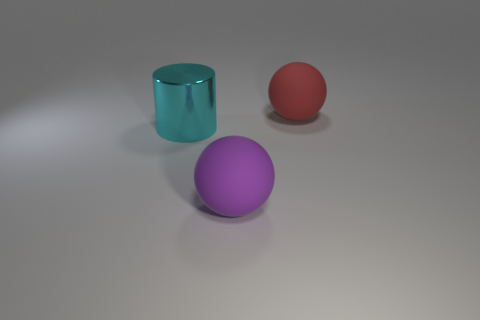There is a large matte sphere that is on the left side of the object behind the big metallic object; what number of large rubber things are right of it?
Provide a short and direct response. 1. Is there a red thing that has the same size as the purple rubber thing?
Provide a succinct answer. Yes. Is the number of big red matte balls that are in front of the purple rubber sphere less than the number of small metallic blocks?
Provide a short and direct response. No. The cyan object that is behind the big matte ball that is in front of the big matte sphere behind the purple rubber sphere is made of what material?
Offer a very short reply. Metal. Is the number of big objects to the right of the big purple matte sphere greater than the number of large purple objects in front of the cylinder?
Ensure brevity in your answer.  No. What number of metal objects are cylinders or large red balls?
Give a very brief answer. 1. What is the big cyan cylinder to the left of the red thing made of?
Offer a terse response. Metal. What number of objects are either big cyan shiny things or large rubber objects that are in front of the big red rubber sphere?
Make the answer very short. 2. There is a cyan object that is the same size as the red thing; what is its shape?
Your answer should be very brief. Cylinder. Is the material of the large sphere in front of the large red object the same as the big cyan thing?
Provide a short and direct response. No. 